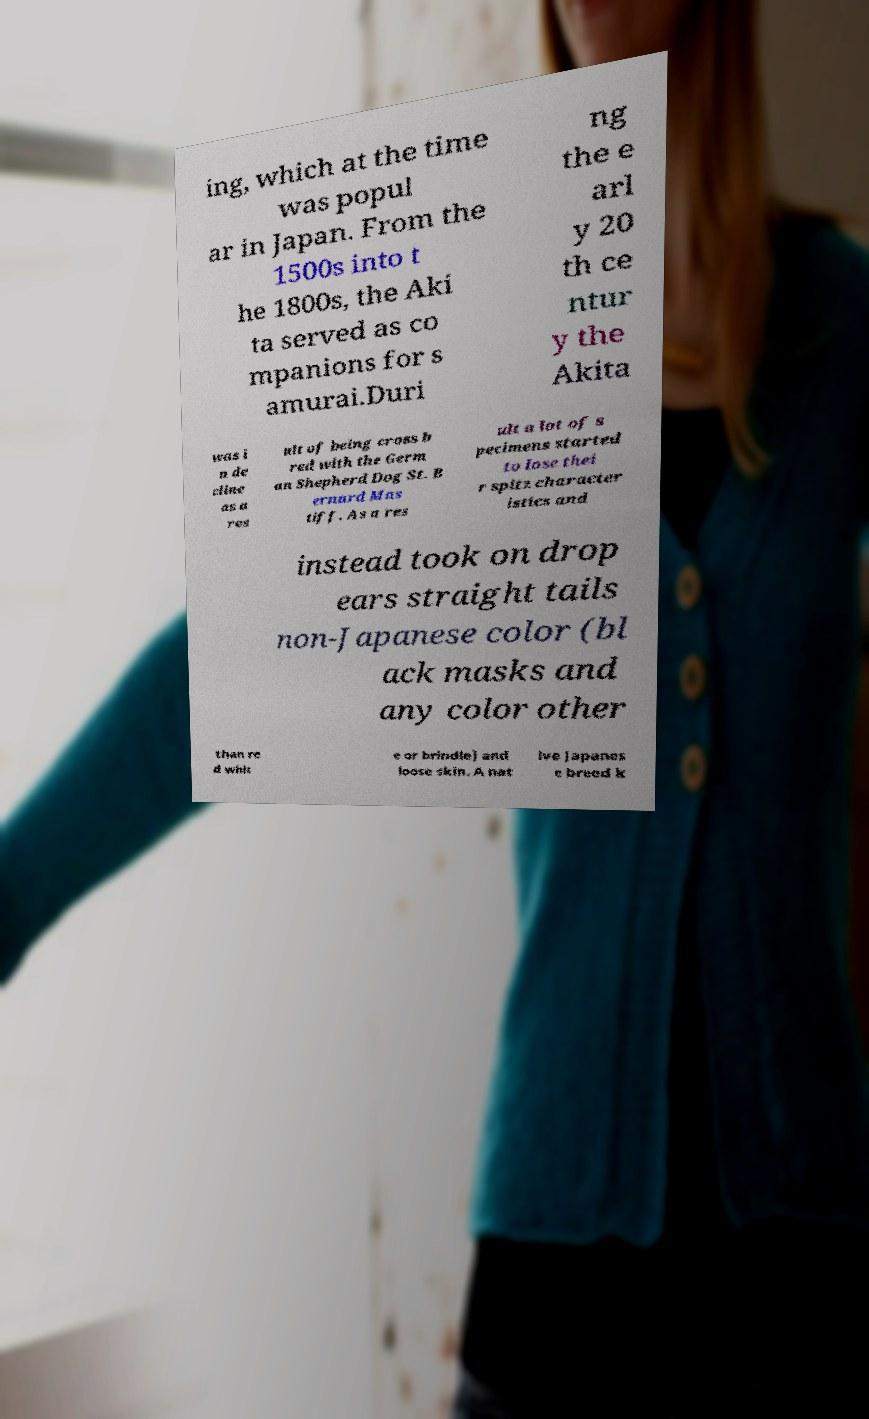Can you read and provide the text displayed in the image?This photo seems to have some interesting text. Can you extract and type it out for me? ing, which at the time was popul ar in Japan. From the 1500s into t he 1800s, the Aki ta served as co mpanions for s amurai.Duri ng the e arl y 20 th ce ntur y the Akita was i n de cline as a res ult of being cross b red with the Germ an Shepherd Dog St. B ernard Mas tiff. As a res ult a lot of s pecimens started to lose thei r spitz character istics and instead took on drop ears straight tails non-Japanese color (bl ack masks and any color other than re d whit e or brindle) and loose skin. A nat ive Japanes e breed k 